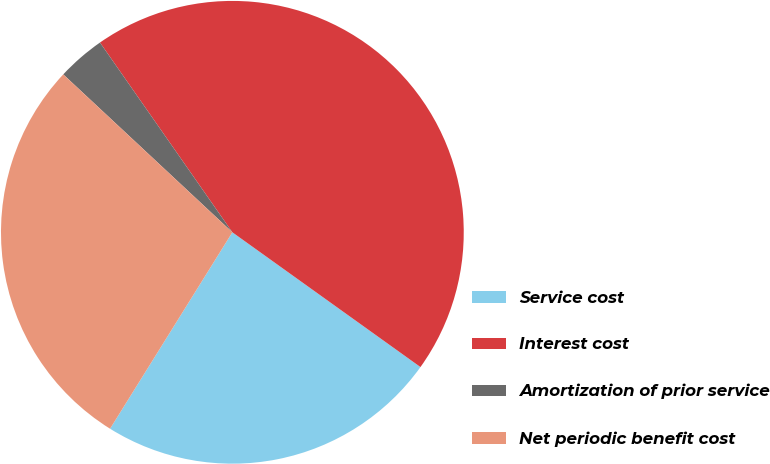Convert chart. <chart><loc_0><loc_0><loc_500><loc_500><pie_chart><fcel>Service cost<fcel>Interest cost<fcel>Amortization of prior service<fcel>Net periodic benefit cost<nl><fcel>23.97%<fcel>44.59%<fcel>3.35%<fcel>28.09%<nl></chart> 